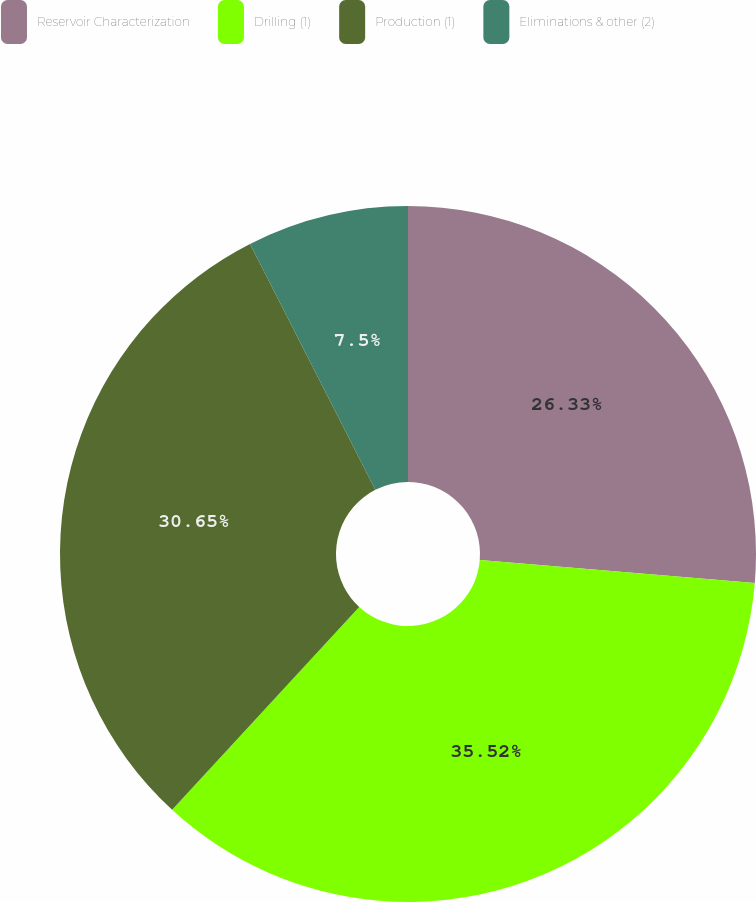<chart> <loc_0><loc_0><loc_500><loc_500><pie_chart><fcel>Reservoir Characterization<fcel>Drilling (1)<fcel>Production (1)<fcel>Eliminations & other (2)<nl><fcel>26.33%<fcel>35.53%<fcel>30.65%<fcel>7.5%<nl></chart> 